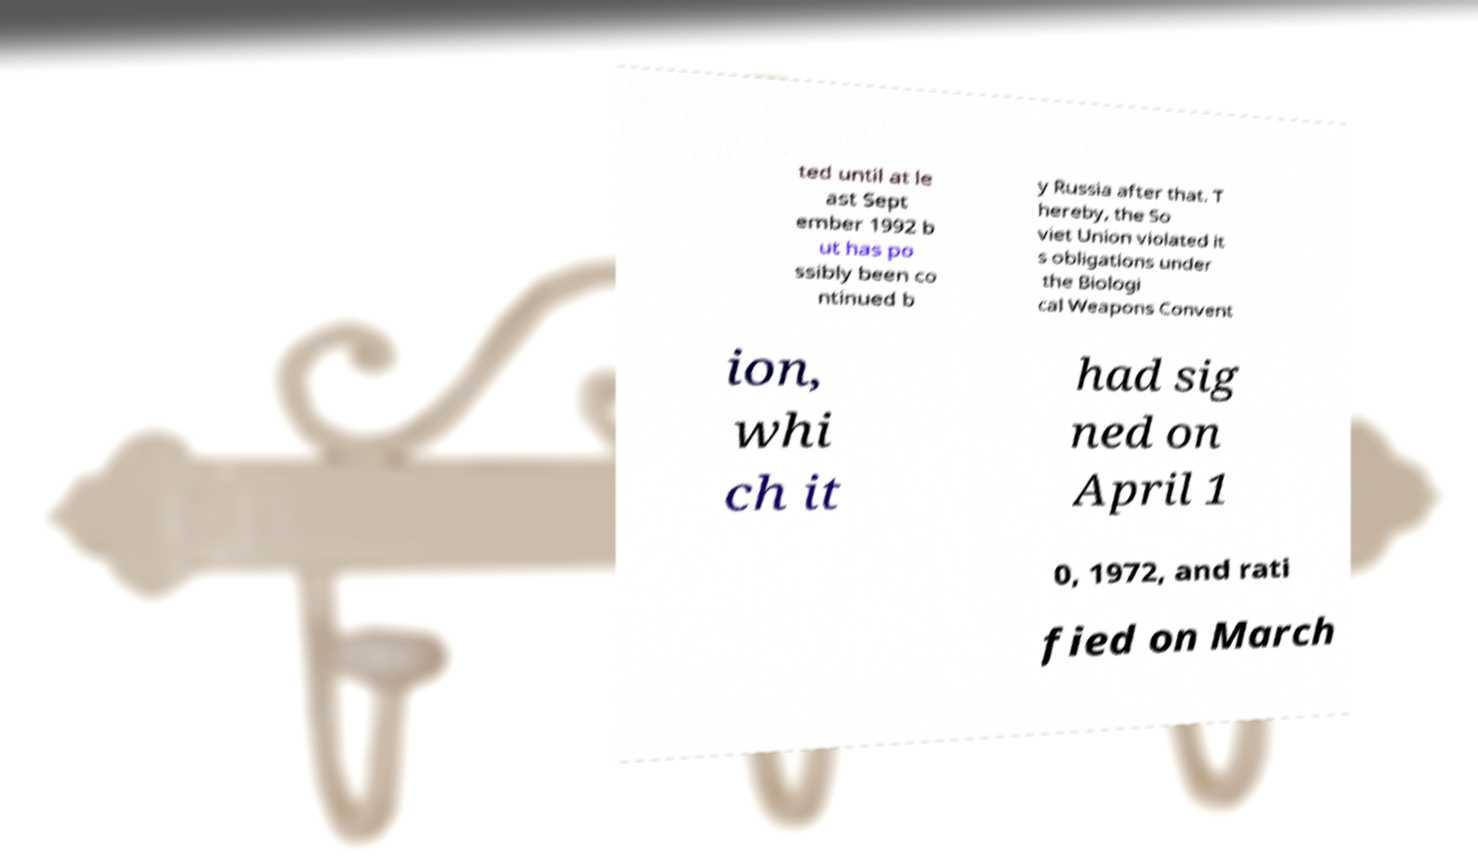Could you extract and type out the text from this image? ted until at le ast Sept ember 1992 b ut has po ssibly been co ntinued b y Russia after that. T hereby, the So viet Union violated it s obligations under the Biologi cal Weapons Convent ion, whi ch it had sig ned on April 1 0, 1972, and rati fied on March 